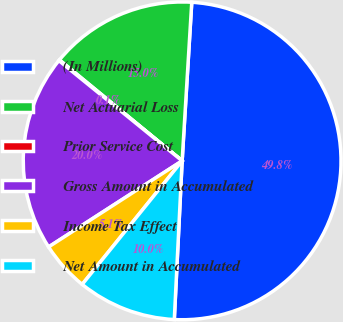Convert chart to OTSL. <chart><loc_0><loc_0><loc_500><loc_500><pie_chart><fcel>(In Millions)<fcel>Net Actuarial Loss<fcel>Prior Service Cost<fcel>Gross Amount in Accumulated<fcel>Income Tax Effect<fcel>Net Amount in Accumulated<nl><fcel>49.82%<fcel>15.01%<fcel>0.09%<fcel>19.98%<fcel>5.06%<fcel>10.04%<nl></chart> 